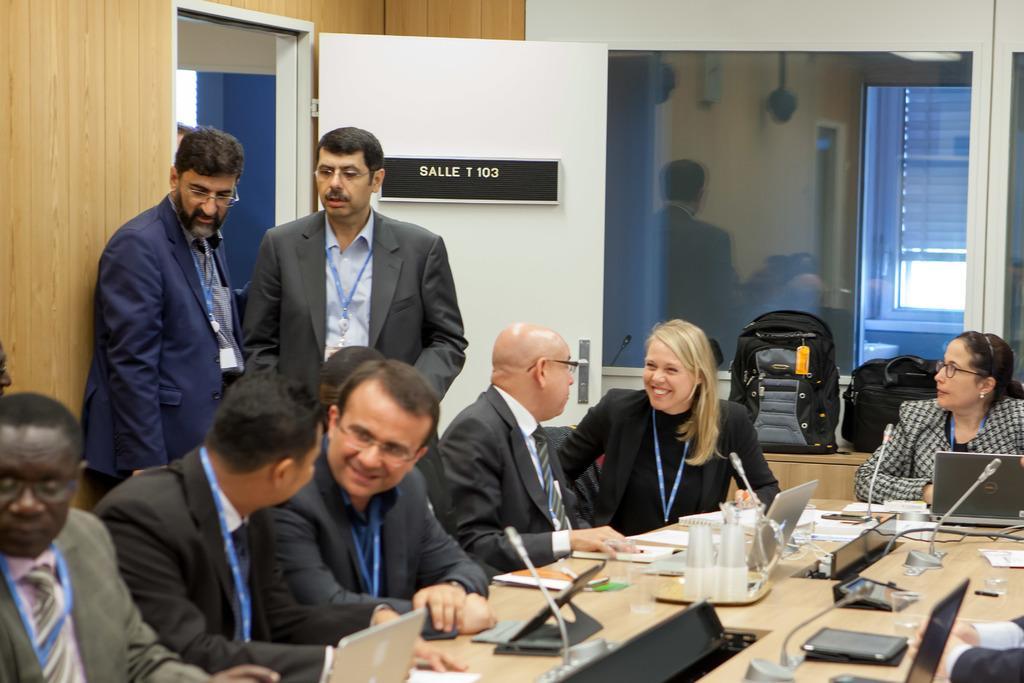How would you summarize this image in a sentence or two? This picture shows people seated on the chairs and speaking to each other and we see few laptops papers and microphones on the table and we see couple of men Standing 